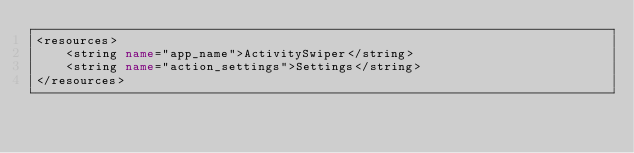Convert code to text. <code><loc_0><loc_0><loc_500><loc_500><_XML_><resources>
    <string name="app_name">ActivitySwiper</string>
    <string name="action_settings">Settings</string>
</resources>
</code> 